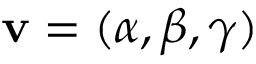<formula> <loc_0><loc_0><loc_500><loc_500>{ v } = ( \alpha , \beta , \gamma )</formula> 